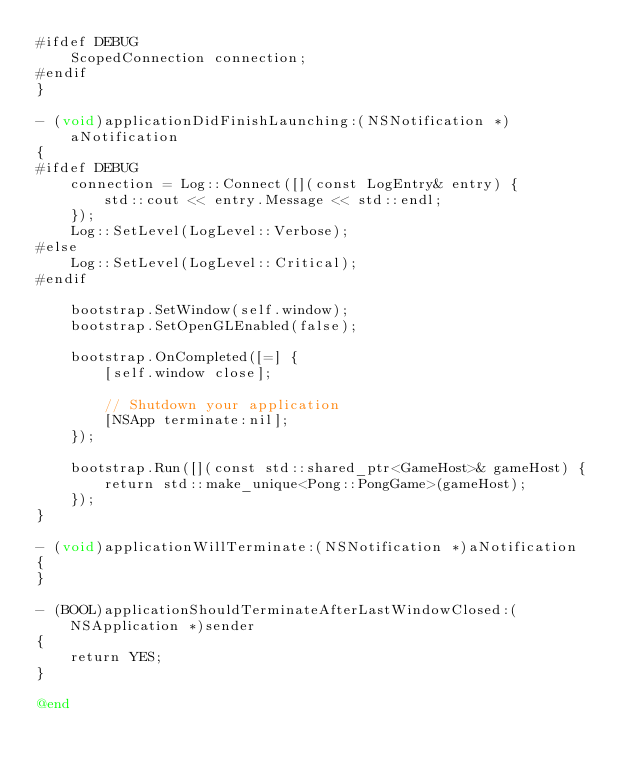Convert code to text. <code><loc_0><loc_0><loc_500><loc_500><_ObjectiveC_>#ifdef DEBUG
    ScopedConnection connection;
#endif
}

- (void)applicationDidFinishLaunching:(NSNotification *)aNotification
{
#ifdef DEBUG
    connection = Log::Connect([](const LogEntry& entry) {
        std::cout << entry.Message << std::endl;
    });
    Log::SetLevel(LogLevel::Verbose);
#else
    Log::SetLevel(LogLevel::Critical);
#endif

    bootstrap.SetWindow(self.window);
    bootstrap.SetOpenGLEnabled(false);

    bootstrap.OnCompleted([=] {
        [self.window close];

        // Shutdown your application
        [NSApp terminate:nil];
    });

    bootstrap.Run([](const std::shared_ptr<GameHost>& gameHost) {
        return std::make_unique<Pong::PongGame>(gameHost);
    });
}

- (void)applicationWillTerminate:(NSNotification *)aNotification
{
}

- (BOOL)applicationShouldTerminateAfterLastWindowClosed:(NSApplication *)sender
{
    return YES;
}

@end
</code> 